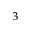<formula> <loc_0><loc_0><loc_500><loc_500>^ { \, 3 }</formula> 